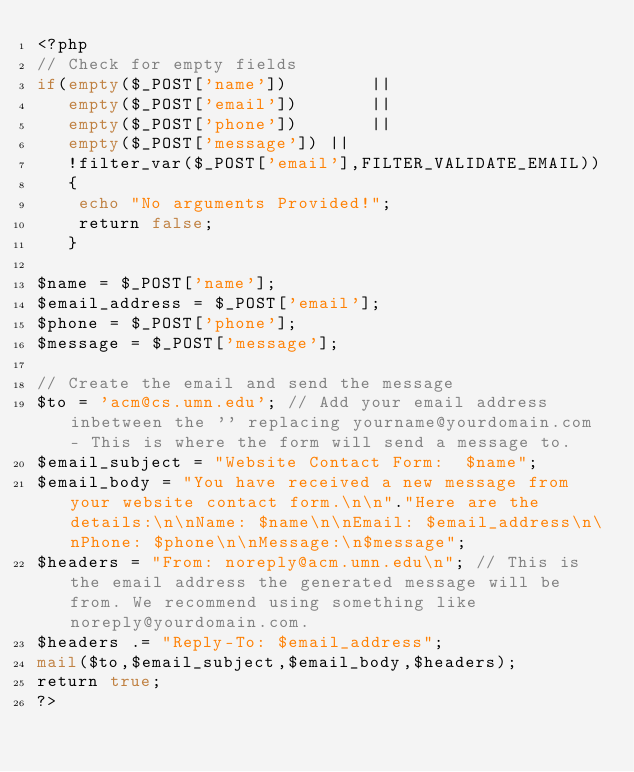<code> <loc_0><loc_0><loc_500><loc_500><_PHP_><?php
// Check for empty fields
if(empty($_POST['name'])  		||
   empty($_POST['email']) 		||
   empty($_POST['phone']) 		||
   empty($_POST['message'])	||
   !filter_var($_POST['email'],FILTER_VALIDATE_EMAIL))
   {
	echo "No arguments Provided!";
	return false;
   }

$name = $_POST['name'];
$email_address = $_POST['email'];
$phone = $_POST['phone'];
$message = $_POST['message'];

// Create the email and send the message
$to = 'acm@cs.umn.edu'; // Add your email address inbetween the '' replacing yourname@yourdomain.com - This is where the form will send a message to.
$email_subject = "Website Contact Form:  $name";
$email_body = "You have received a new message from your website contact form.\n\n"."Here are the details:\n\nName: $name\n\nEmail: $email_address\n\nPhone: $phone\n\nMessage:\n$message";
$headers = "From: noreply@acm.umn.edu\n"; // This is the email address the generated message will be from. We recommend using something like noreply@yourdomain.com.
$headers .= "Reply-To: $email_address";
mail($to,$email_subject,$email_body,$headers);
return true;
?>
</code> 